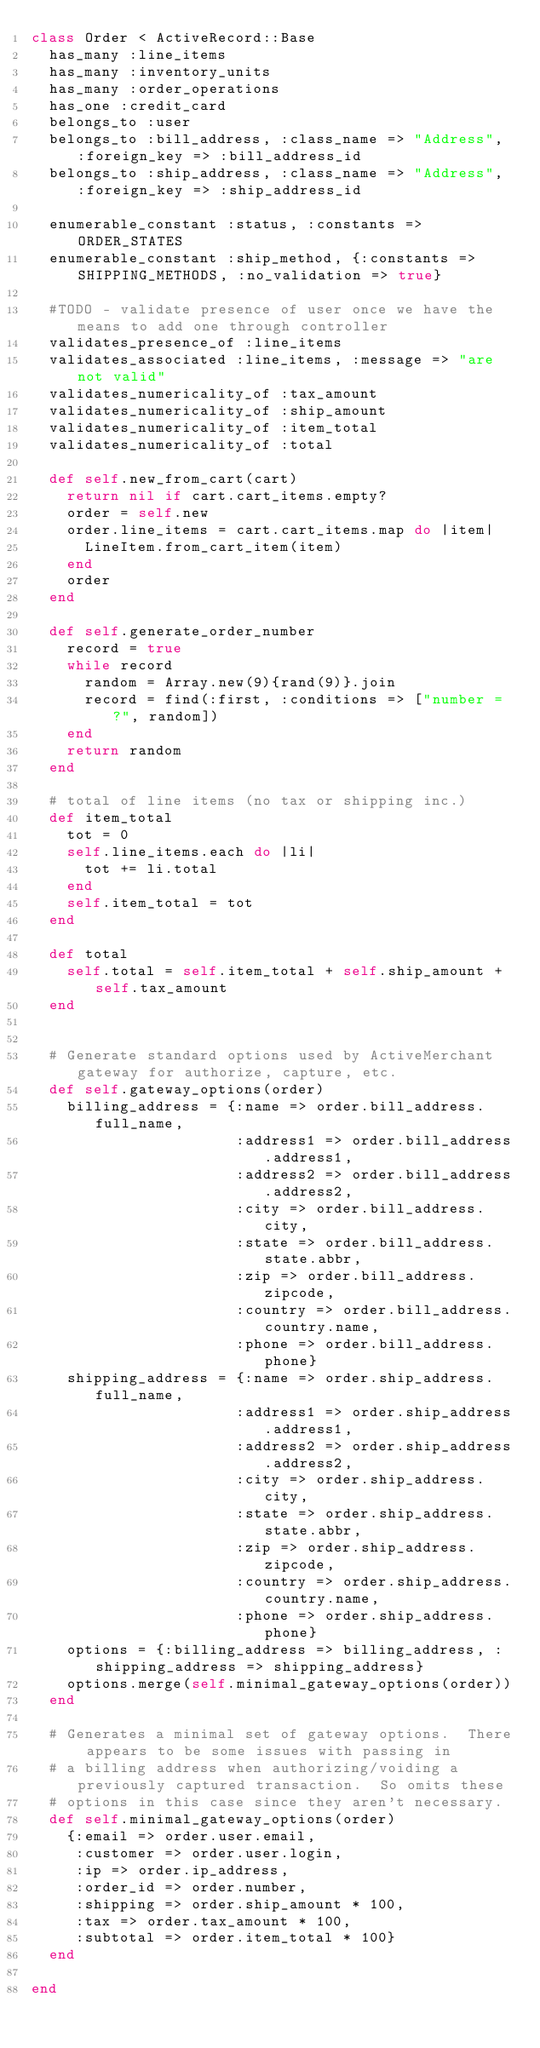<code> <loc_0><loc_0><loc_500><loc_500><_Ruby_>class Order < ActiveRecord::Base  
  has_many :line_items
  has_many :inventory_units
  has_many :order_operations
  has_one :credit_card
  belongs_to :user
  belongs_to :bill_address, :class_name => "Address", :foreign_key => :bill_address_id
  belongs_to :ship_address, :class_name => "Address", :foreign_key => :ship_address_id

  enumerable_constant :status, :constants => ORDER_STATES
  enumerable_constant :ship_method, {:constants => SHIPPING_METHODS, :no_validation => true}

  #TODO - validate presence of user once we have the means to add one through controller
  validates_presence_of :line_items
  validates_associated :line_items, :message => "are not valid"
  validates_numericality_of :tax_amount
  validates_numericality_of :ship_amount
  validates_numericality_of :item_total
  validates_numericality_of :total

  def self.new_from_cart(cart)
    return nil if cart.cart_items.empty?
    order = self.new
    order.line_items = cart.cart_items.map do |item|
      LineItem.from_cart_item(item)
    end
    order
  end

  def self.generate_order_number
    record = true
    while record
      random = Array.new(9){rand(9)}.join
      record = find(:first, :conditions => ["number = ?", random])
    end
    return random
  end

  # total of line items (no tax or shipping inc.)
  def item_total
    tot = 0
    self.line_items.each do |li|
      tot += li.total
    end
    self.item_total = tot
  end
  
  def total
    self.total = self.item_total + self.ship_amount + self.tax_amount
  end


  # Generate standard options used by ActiveMerchant gateway for authorize, capture, etc. 
  def self.gateway_options(order)
    billing_address = {:name => order.bill_address.full_name,
                       :address1 => order.bill_address.address1,
                       :address2 => order.bill_address.address2, 
                       :city => order.bill_address.city,
                       :state => order.bill_address.state.abbr, 
                       :zip => order.bill_address.zipcode,
                       :country => order.bill_address.country.name,
                       :phone => order.bill_address.phone}
    shipping_address = {:name => order.ship_address.full_name,
                       :address1 => order.ship_address.address1,
                       :address2 => order.ship_address.address2, 
                       :city => order.ship_address.city,
                       :state => order.ship_address.state.abbr, 
                       :zip => order.ship_address.zipcode,
                       :country => order.ship_address.country.name,
                       :phone => order.ship_address.phone}
    options = {:billing_address => billing_address, :shipping_address => shipping_address}
    options.merge(self.minimal_gateway_options(order))
  end
 
  # Generates a minimal set of gateway options.  There appears to be some issues with passing in 
  # a billing address when authorizing/voiding a previously captured transaction.  So omits these 
  # options in this case since they aren't necessary.  
  def self.minimal_gateway_options(order)
    {:email => order.user.email, 
     :customer => order.user.login, 
     :ip => order.ip_address, 
     :order_id => order.number,
     :shipping => order.ship_amount * 100,
     :tax => order.tax_amount * 100, 
     :subtotal => order.item_total * 100}  
  end

end
</code> 